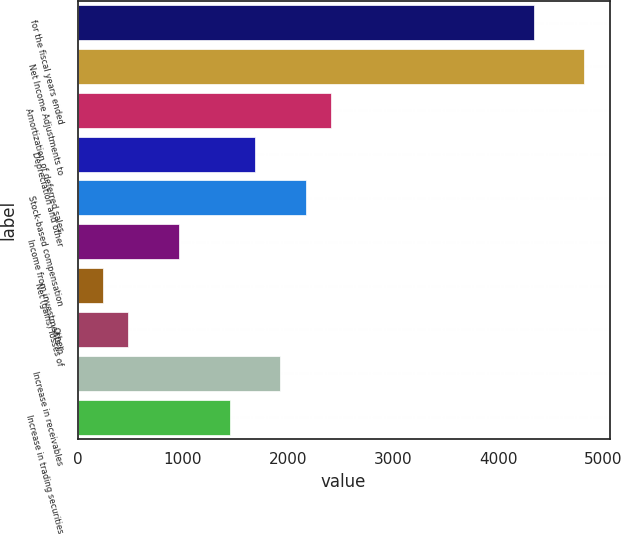Convert chart to OTSL. <chart><loc_0><loc_0><loc_500><loc_500><bar_chart><fcel>for the fiscal years ended<fcel>Net Income Adjustments to<fcel>Amortization of deferred sales<fcel>Depreciation and other<fcel>Stock-based compensation<fcel>Income from investments in<fcel>Net (gains) losses of<fcel>Other<fcel>Increase in receivables<fcel>Increase in trading securities<nl><fcel>4338.98<fcel>4820.8<fcel>2411.7<fcel>1688.97<fcel>2170.79<fcel>966.24<fcel>243.51<fcel>484.42<fcel>1929.88<fcel>1448.06<nl></chart> 